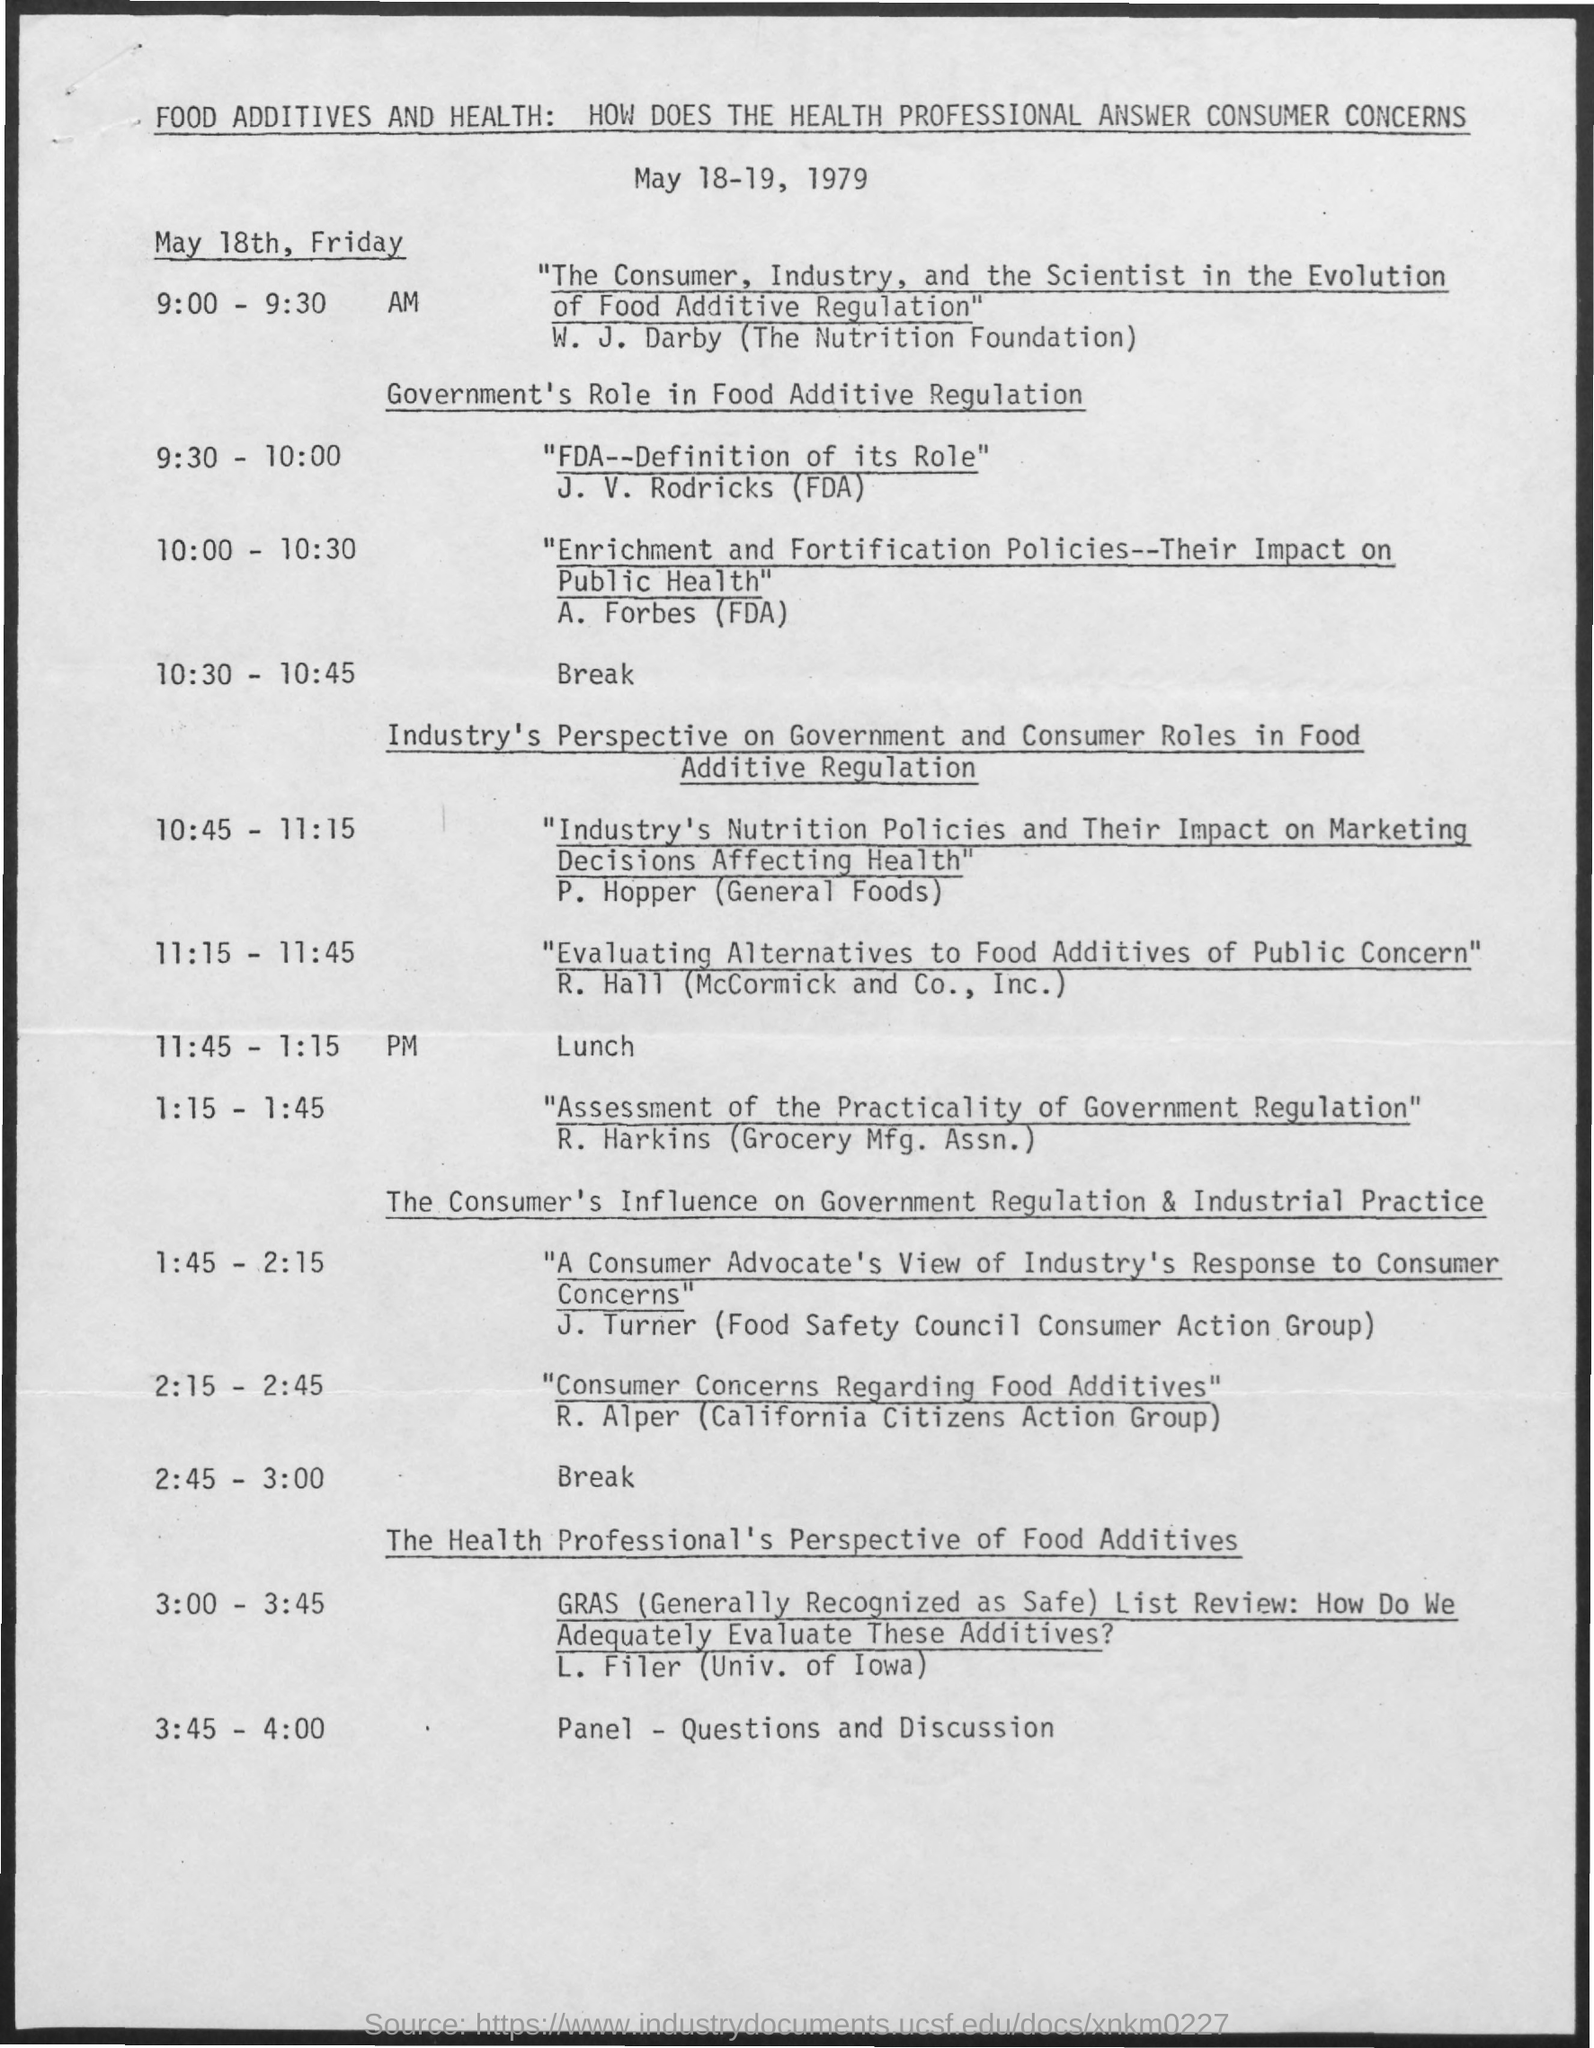Give some essential details in this illustration. The lunch time is from 11:45 AM to 1:15 PM. 